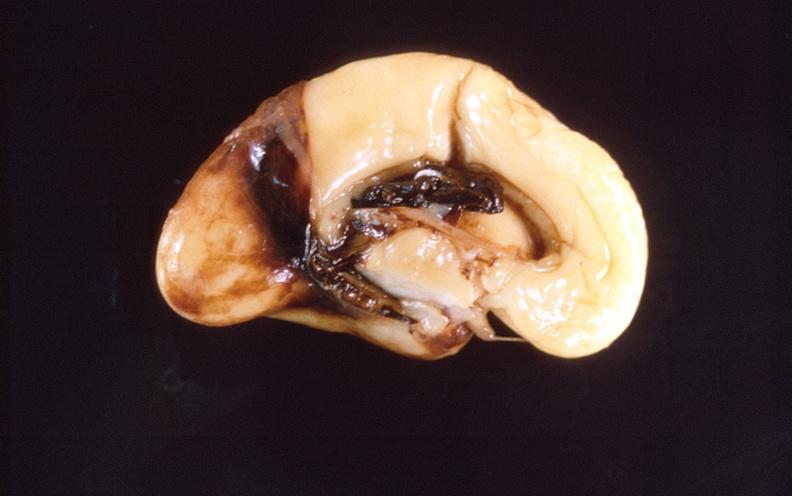what is present?
Answer the question using a single word or phrase. Nervous 